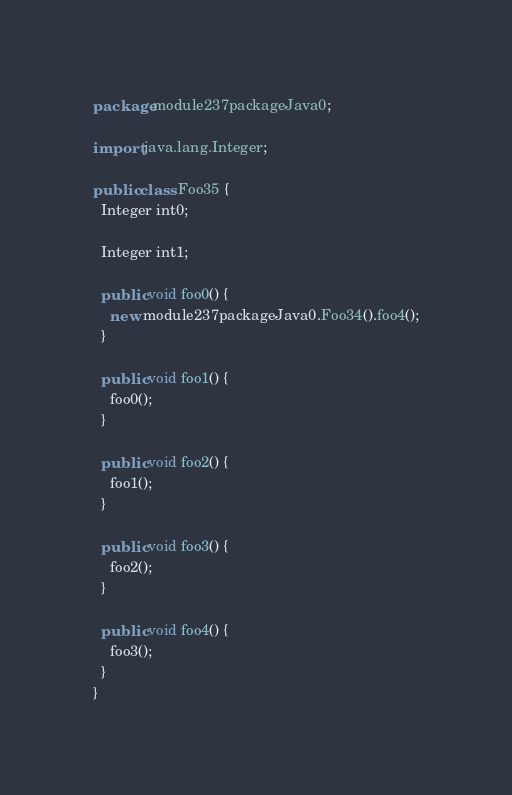<code> <loc_0><loc_0><loc_500><loc_500><_Java_>package module237packageJava0;

import java.lang.Integer;

public class Foo35 {
  Integer int0;

  Integer int1;

  public void foo0() {
    new module237packageJava0.Foo34().foo4();
  }

  public void foo1() {
    foo0();
  }

  public void foo2() {
    foo1();
  }

  public void foo3() {
    foo2();
  }

  public void foo4() {
    foo3();
  }
}
</code> 